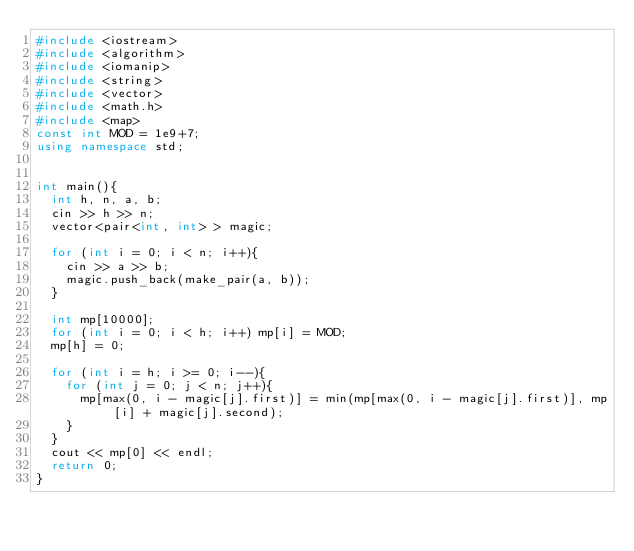<code> <loc_0><loc_0><loc_500><loc_500><_C++_>#include <iostream>
#include <algorithm>
#include <iomanip>
#include <string>
#include <vector>
#include <math.h>
#include <map>
const int MOD = 1e9+7;
using namespace std;


int main(){
	int h, n, a, b;
	cin >> h >> n;
	vector<pair<int, int> > magic;

	for (int i = 0; i < n; i++){
		cin >> a >> b;
		magic.push_back(make_pair(a, b));
	}

	int mp[10000];
	for (int i = 0; i < h; i++) mp[i] = MOD;
	mp[h] = 0;

	for (int i = h; i >= 0; i--){
		for (int j = 0; j < n; j++){
			mp[max(0, i - magic[j].first)] = min(mp[max(0, i - magic[j].first)], mp[i] + magic[j].second);
		}
	}
	cout << mp[0] << endl;
	return 0;
}
</code> 